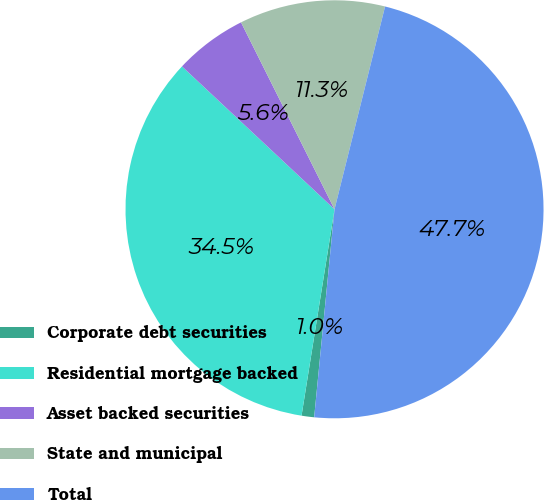Convert chart. <chart><loc_0><loc_0><loc_500><loc_500><pie_chart><fcel>Corporate debt securities<fcel>Residential mortgage backed<fcel>Asset backed securities<fcel>State and municipal<fcel>Total<nl><fcel>0.97%<fcel>34.46%<fcel>5.64%<fcel>11.27%<fcel>47.67%<nl></chart> 